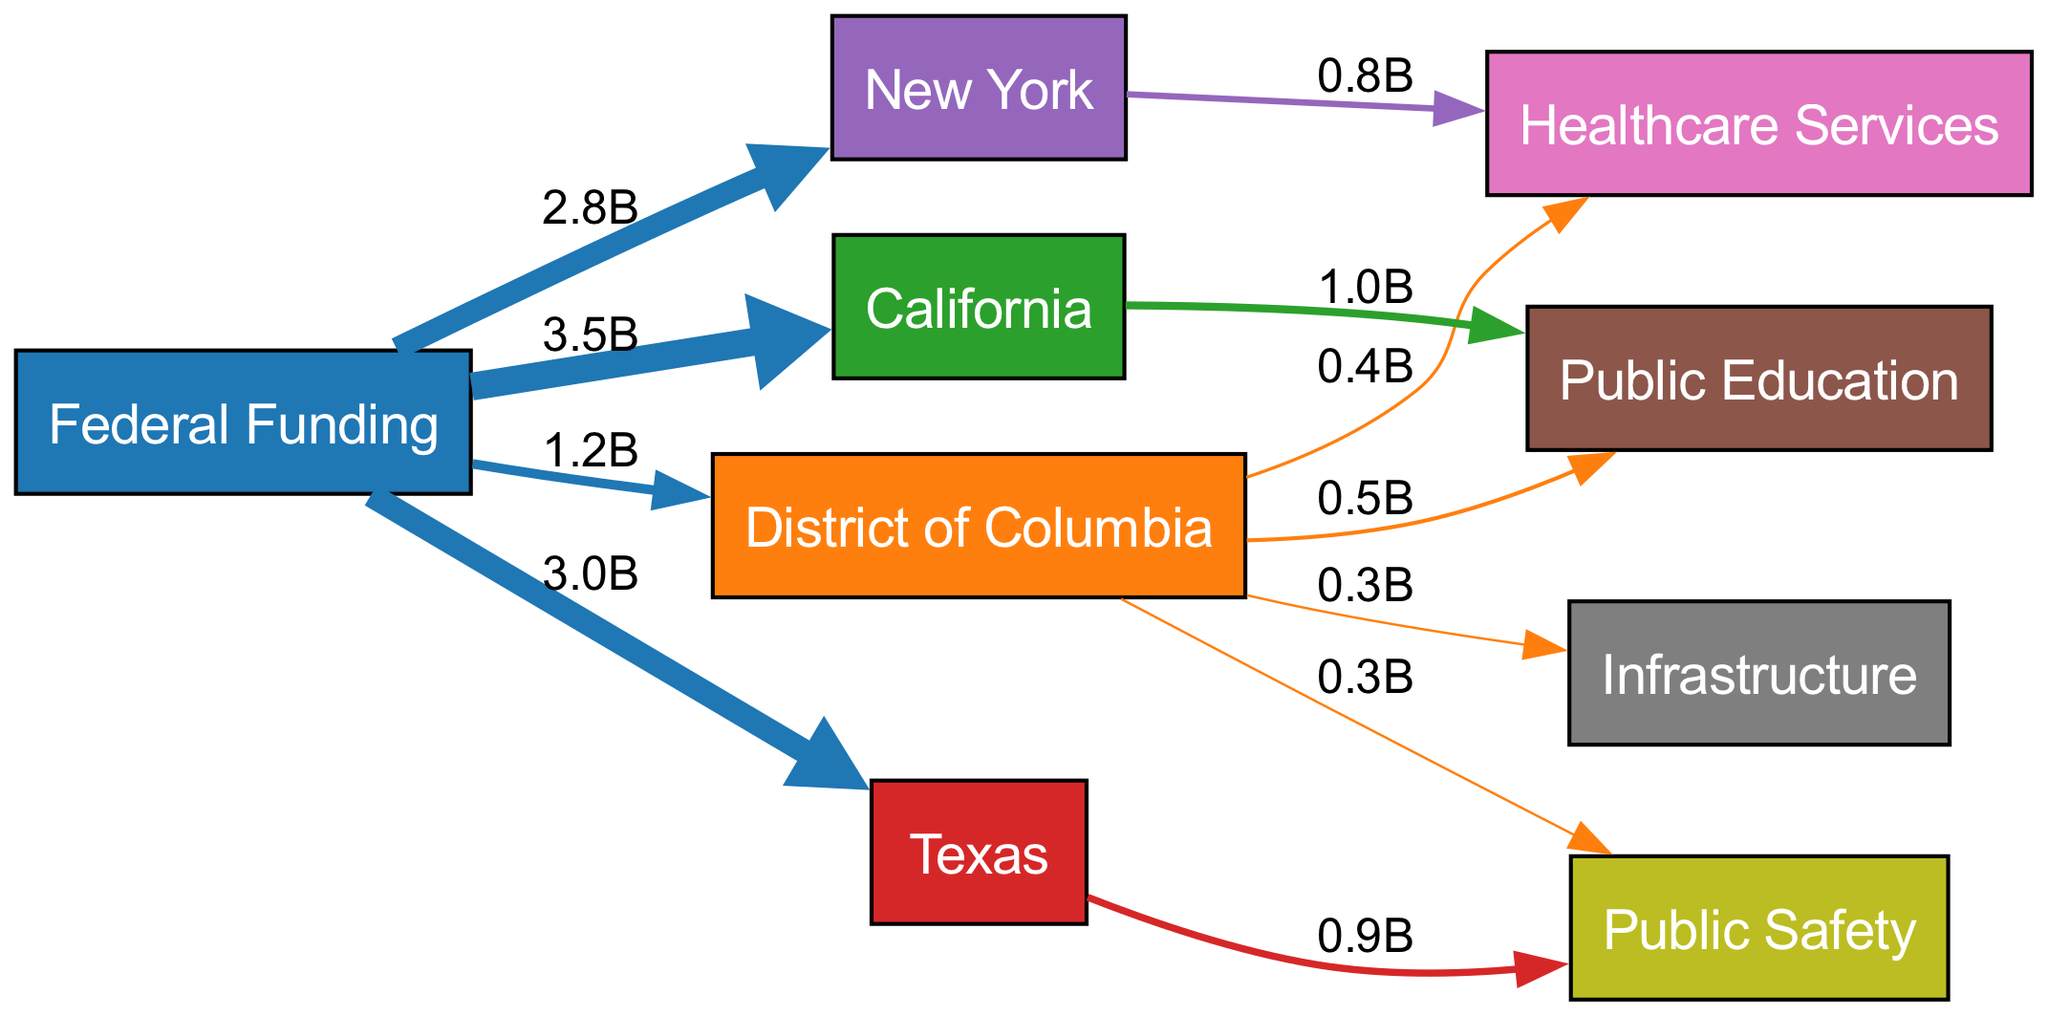How much federal funding does D.C. receive? The diagram shows a direct flow from "Federal Funding" to "D.C." with a value labeled as 1.2 billion.
Answer: 1.2 billion What is the total federal funding received by California? The link from "Federal Funding" to "California" indicates a value of 3.5 billion.
Answer: 3.5 billion Which category does D.C. allocate the least amount of its federal funding to? By examining the flows from "D.C." to its local services, "Healthcare Services" has a value of 0.4 billion, which is lower than the other categories.
Answer: Healthcare Services What is the total federal funding allocated to public education in D.C. and California combined? The federal funding to "Public Education" in "D.C." is 0.5 billion and in "California" is 1.0 billion; therefore, their combined total is 0.5 + 1.0 = 1.5 billion.
Answer: 1.5 billion Which state out of D.C., California, Texas, and New York receives the most federal funding? By comparing the values: D.C. receives 1.2 billion, California receives 3.5 billion, Texas receives 3.0 billion, and New York receives 2.8 billion. California has the highest value of 3.5 billion.
Answer: California How does the flow of federal funding to D.C. compare to the funding for public safety in Texas? D.C. receives 1.2 billion in total federal funding, while the specific allocation for "Public Safety" in Texas is 0.9 billion. Therefore, D.C. receives more overall funding than Texas does for public safety.
Answer: More What percentage of D.C. federal funding goes to public education? D.C. allocates 0.5 billion to "Public Education" from a total of 1.2 billion received. The percentage is calculated as (0.5/1.2) * 100, which equals approximately 41.67%.
Answer: Approximately 41.67% Which service receives equal funding from D.C. based on the diagram? The diagram shows that both "Infrastructure" and "Public Safety" in D.C. receive equal allocations of 0.3 billion.
Answer: Infrastructure and Public Safety Which state receives the lowest federal funding allocation? In the visual representation, D.C. receives 1.2 billion, while Texas receives 3.0 billion, California receives 3.5 billion, and New York receives 2.8 billion; therefore, D.C. has the lowest federal funding.
Answer: D.C 